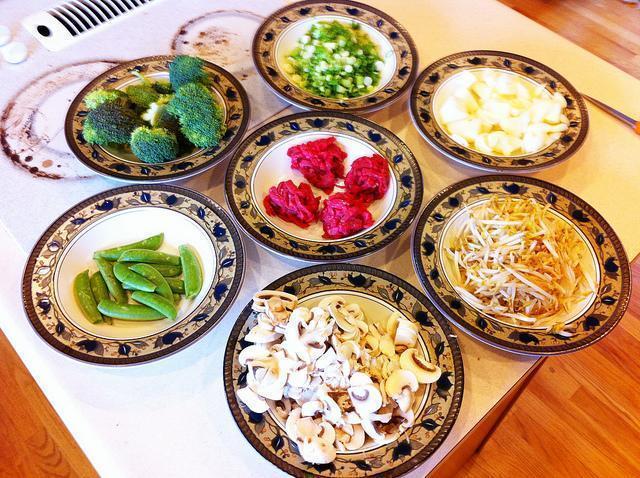How many plates are on the table?
Make your selection from the four choices given to correctly answer the question.
Options: One, two, seven, four. Seven. 